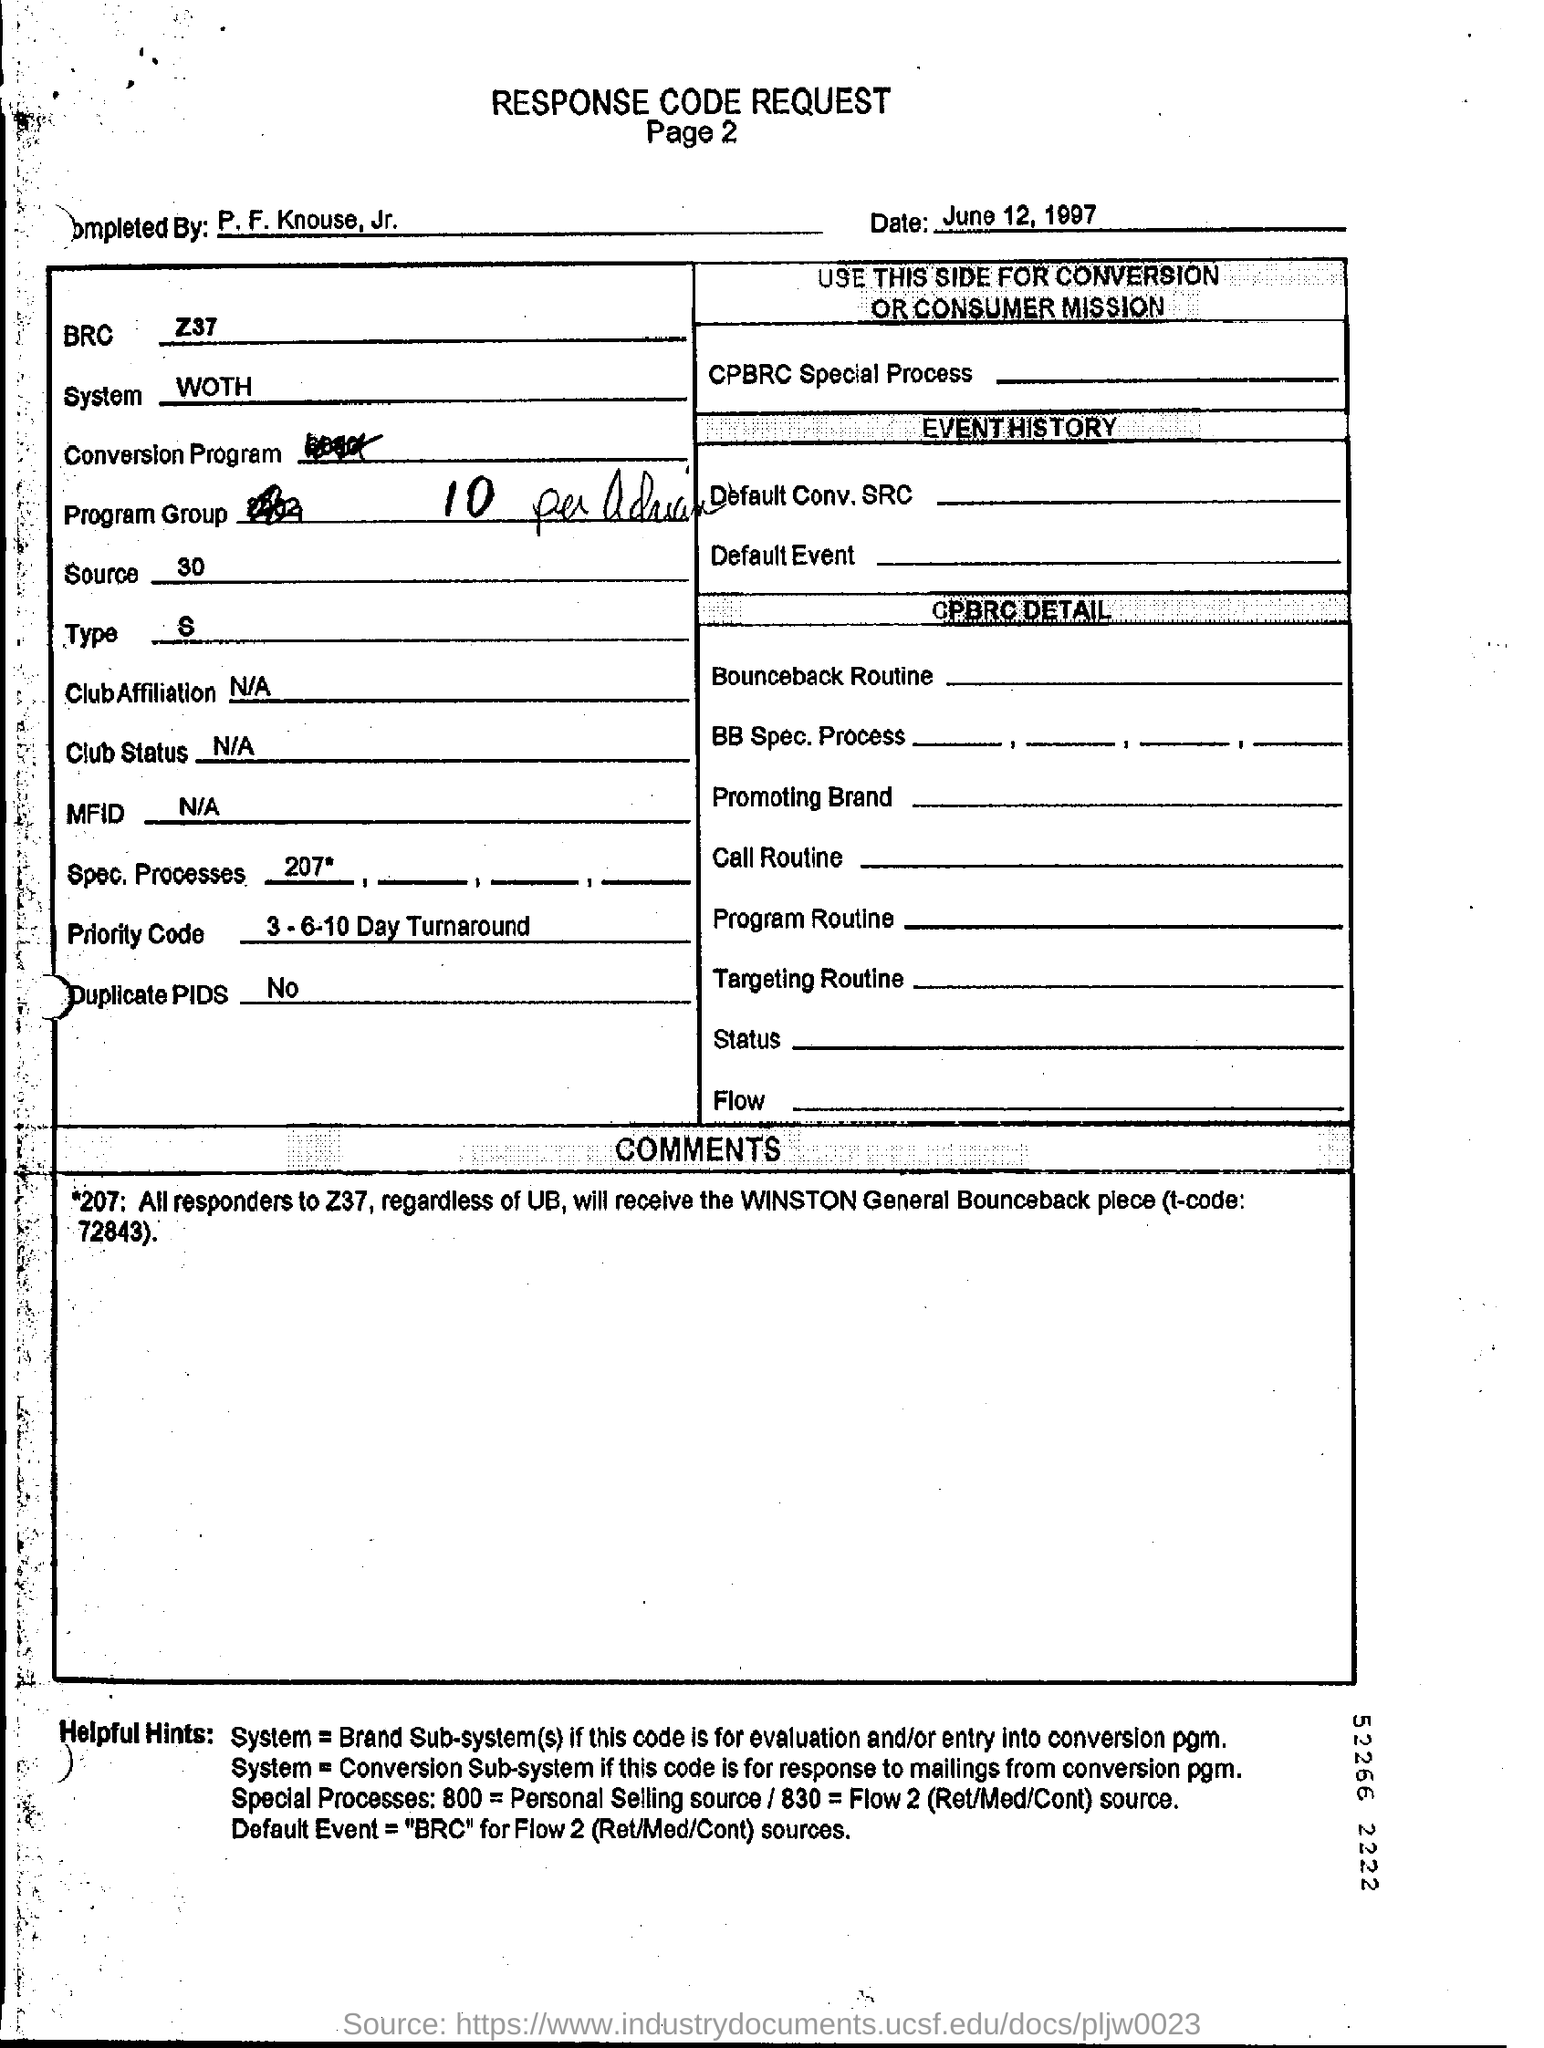What is the date mentioned in this form?
Keep it short and to the point. June 12, 1997. Are there any Duplicate PIDS according to the table?
Your answer should be compact. No. What is the Priority Code?
Provide a short and direct response. 3-6-10 Day Turnaround. 